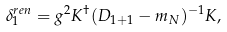<formula> <loc_0><loc_0><loc_500><loc_500>\delta ^ { r e n } _ { 1 } = g ^ { 2 } K ^ { \dagger } ( D _ { 1 + 1 } - m _ { N } ) ^ { - 1 } K ,</formula> 